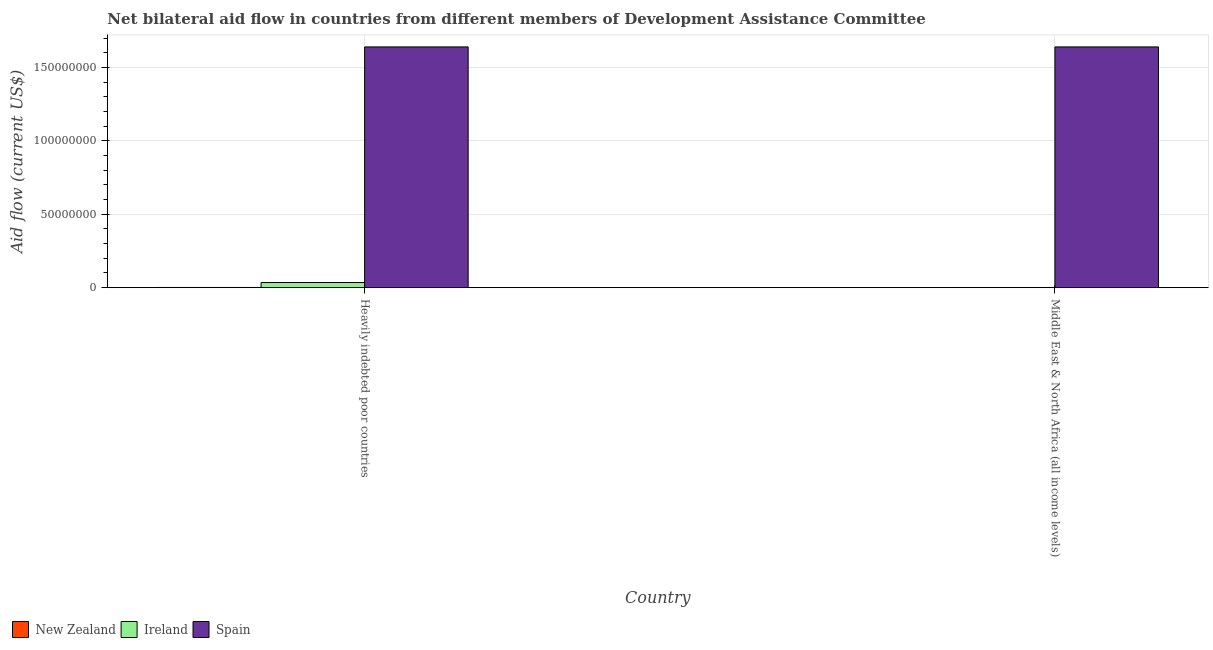Are the number of bars per tick equal to the number of legend labels?
Keep it short and to the point. Yes. How many bars are there on the 2nd tick from the right?
Your answer should be very brief. 3. What is the label of the 1st group of bars from the left?
Your response must be concise. Heavily indebted poor countries. In how many cases, is the number of bars for a given country not equal to the number of legend labels?
Your response must be concise. 0. What is the amount of aid provided by ireland in Heavily indebted poor countries?
Provide a short and direct response. 3.50e+06. Across all countries, what is the maximum amount of aid provided by spain?
Offer a very short reply. 1.64e+08. Across all countries, what is the minimum amount of aid provided by new zealand?
Offer a very short reply. 10000. In which country was the amount of aid provided by ireland maximum?
Offer a very short reply. Heavily indebted poor countries. In which country was the amount of aid provided by ireland minimum?
Offer a terse response. Middle East & North Africa (all income levels). What is the total amount of aid provided by new zealand in the graph?
Give a very brief answer. 1.50e+05. What is the difference between the amount of aid provided by new zealand in Heavily indebted poor countries and that in Middle East & North Africa (all income levels)?
Provide a short and direct response. 1.30e+05. What is the difference between the amount of aid provided by spain in Heavily indebted poor countries and the amount of aid provided by new zealand in Middle East & North Africa (all income levels)?
Provide a short and direct response. 1.64e+08. What is the average amount of aid provided by spain per country?
Offer a very short reply. 1.64e+08. What is the difference between the amount of aid provided by new zealand and amount of aid provided by spain in Middle East & North Africa (all income levels)?
Offer a very short reply. -1.64e+08. In how many countries, is the amount of aid provided by ireland greater than the average amount of aid provided by ireland taken over all countries?
Your response must be concise. 1. What does the 1st bar from the right in Heavily indebted poor countries represents?
Provide a short and direct response. Spain. Is it the case that in every country, the sum of the amount of aid provided by new zealand and amount of aid provided by ireland is greater than the amount of aid provided by spain?
Your answer should be very brief. No. How many bars are there?
Give a very brief answer. 6. Are all the bars in the graph horizontal?
Ensure brevity in your answer.  No. How many countries are there in the graph?
Give a very brief answer. 2. What is the difference between two consecutive major ticks on the Y-axis?
Your answer should be compact. 5.00e+07. Does the graph contain grids?
Offer a terse response. Yes. What is the title of the graph?
Offer a terse response. Net bilateral aid flow in countries from different members of Development Assistance Committee. What is the Aid flow (current US$) in New Zealand in Heavily indebted poor countries?
Your answer should be compact. 1.40e+05. What is the Aid flow (current US$) of Ireland in Heavily indebted poor countries?
Offer a terse response. 3.50e+06. What is the Aid flow (current US$) of Spain in Heavily indebted poor countries?
Ensure brevity in your answer.  1.64e+08. What is the Aid flow (current US$) in New Zealand in Middle East & North Africa (all income levels)?
Your answer should be very brief. 10000. What is the Aid flow (current US$) in Ireland in Middle East & North Africa (all income levels)?
Make the answer very short. 1.20e+05. What is the Aid flow (current US$) in Spain in Middle East & North Africa (all income levels)?
Provide a succinct answer. 1.64e+08. Across all countries, what is the maximum Aid flow (current US$) in New Zealand?
Ensure brevity in your answer.  1.40e+05. Across all countries, what is the maximum Aid flow (current US$) in Ireland?
Provide a succinct answer. 3.50e+06. Across all countries, what is the maximum Aid flow (current US$) in Spain?
Your response must be concise. 1.64e+08. Across all countries, what is the minimum Aid flow (current US$) of Spain?
Your answer should be compact. 1.64e+08. What is the total Aid flow (current US$) of Ireland in the graph?
Make the answer very short. 3.62e+06. What is the total Aid flow (current US$) in Spain in the graph?
Your answer should be compact. 3.28e+08. What is the difference between the Aid flow (current US$) in Ireland in Heavily indebted poor countries and that in Middle East & North Africa (all income levels)?
Offer a very short reply. 3.38e+06. What is the difference between the Aid flow (current US$) in Spain in Heavily indebted poor countries and that in Middle East & North Africa (all income levels)?
Ensure brevity in your answer.  0. What is the difference between the Aid flow (current US$) in New Zealand in Heavily indebted poor countries and the Aid flow (current US$) in Spain in Middle East & North Africa (all income levels)?
Give a very brief answer. -1.64e+08. What is the difference between the Aid flow (current US$) in Ireland in Heavily indebted poor countries and the Aid flow (current US$) in Spain in Middle East & North Africa (all income levels)?
Your answer should be compact. -1.60e+08. What is the average Aid flow (current US$) of New Zealand per country?
Make the answer very short. 7.50e+04. What is the average Aid flow (current US$) of Ireland per country?
Provide a short and direct response. 1.81e+06. What is the average Aid flow (current US$) of Spain per country?
Your answer should be very brief. 1.64e+08. What is the difference between the Aid flow (current US$) in New Zealand and Aid flow (current US$) in Ireland in Heavily indebted poor countries?
Your answer should be compact. -3.36e+06. What is the difference between the Aid flow (current US$) in New Zealand and Aid flow (current US$) in Spain in Heavily indebted poor countries?
Your answer should be very brief. -1.64e+08. What is the difference between the Aid flow (current US$) of Ireland and Aid flow (current US$) of Spain in Heavily indebted poor countries?
Give a very brief answer. -1.60e+08. What is the difference between the Aid flow (current US$) in New Zealand and Aid flow (current US$) in Spain in Middle East & North Africa (all income levels)?
Keep it short and to the point. -1.64e+08. What is the difference between the Aid flow (current US$) of Ireland and Aid flow (current US$) of Spain in Middle East & North Africa (all income levels)?
Give a very brief answer. -1.64e+08. What is the ratio of the Aid flow (current US$) of New Zealand in Heavily indebted poor countries to that in Middle East & North Africa (all income levels)?
Your answer should be compact. 14. What is the ratio of the Aid flow (current US$) in Ireland in Heavily indebted poor countries to that in Middle East & North Africa (all income levels)?
Offer a terse response. 29.17. What is the difference between the highest and the second highest Aid flow (current US$) in New Zealand?
Ensure brevity in your answer.  1.30e+05. What is the difference between the highest and the second highest Aid flow (current US$) in Ireland?
Your answer should be compact. 3.38e+06. What is the difference between the highest and the second highest Aid flow (current US$) of Spain?
Make the answer very short. 0. What is the difference between the highest and the lowest Aid flow (current US$) in New Zealand?
Offer a terse response. 1.30e+05. What is the difference between the highest and the lowest Aid flow (current US$) in Ireland?
Provide a short and direct response. 3.38e+06. 